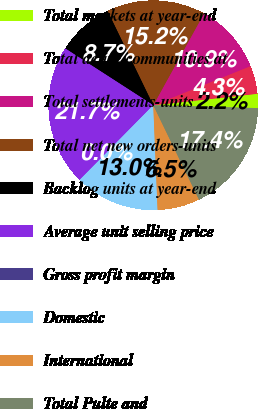Convert chart. <chart><loc_0><loc_0><loc_500><loc_500><pie_chart><fcel>Total markets at year-end<fcel>Total active communities at<fcel>Total settlements-units<fcel>Total net new orders-units<fcel>Backlog units at year-end<fcel>Average unit selling price<fcel>Gross profit margin<fcel>Domestic<fcel>International<fcel>Total Pulte and<nl><fcel>2.18%<fcel>4.35%<fcel>10.87%<fcel>15.22%<fcel>8.7%<fcel>21.74%<fcel>0.0%<fcel>13.04%<fcel>6.52%<fcel>17.39%<nl></chart> 